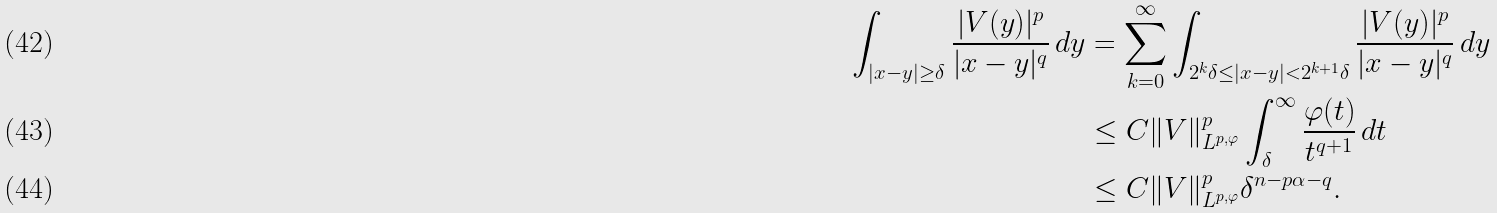Convert formula to latex. <formula><loc_0><loc_0><loc_500><loc_500>\int _ { | x - y | \geq \delta } \frac { | V ( y ) | ^ { p } } { | x - y | ^ { q } } \, d y & = \sum _ { k = 0 } ^ { \infty } \int _ { 2 ^ { k } \delta \leq | x - y | < 2 ^ { k + 1 } \delta } \frac { | V ( y ) | ^ { p } } { | x - y | ^ { q } } \, d y \\ & \leq C \| V \| _ { L ^ { p , \varphi } } ^ { p } \int _ { \delta } ^ { \infty } \frac { \varphi ( t ) } { t ^ { q + 1 } } \, d t \\ & \leq C \| V \| _ { L ^ { p , \varphi } } ^ { p } \delta ^ { n - p \alpha - q } .</formula> 